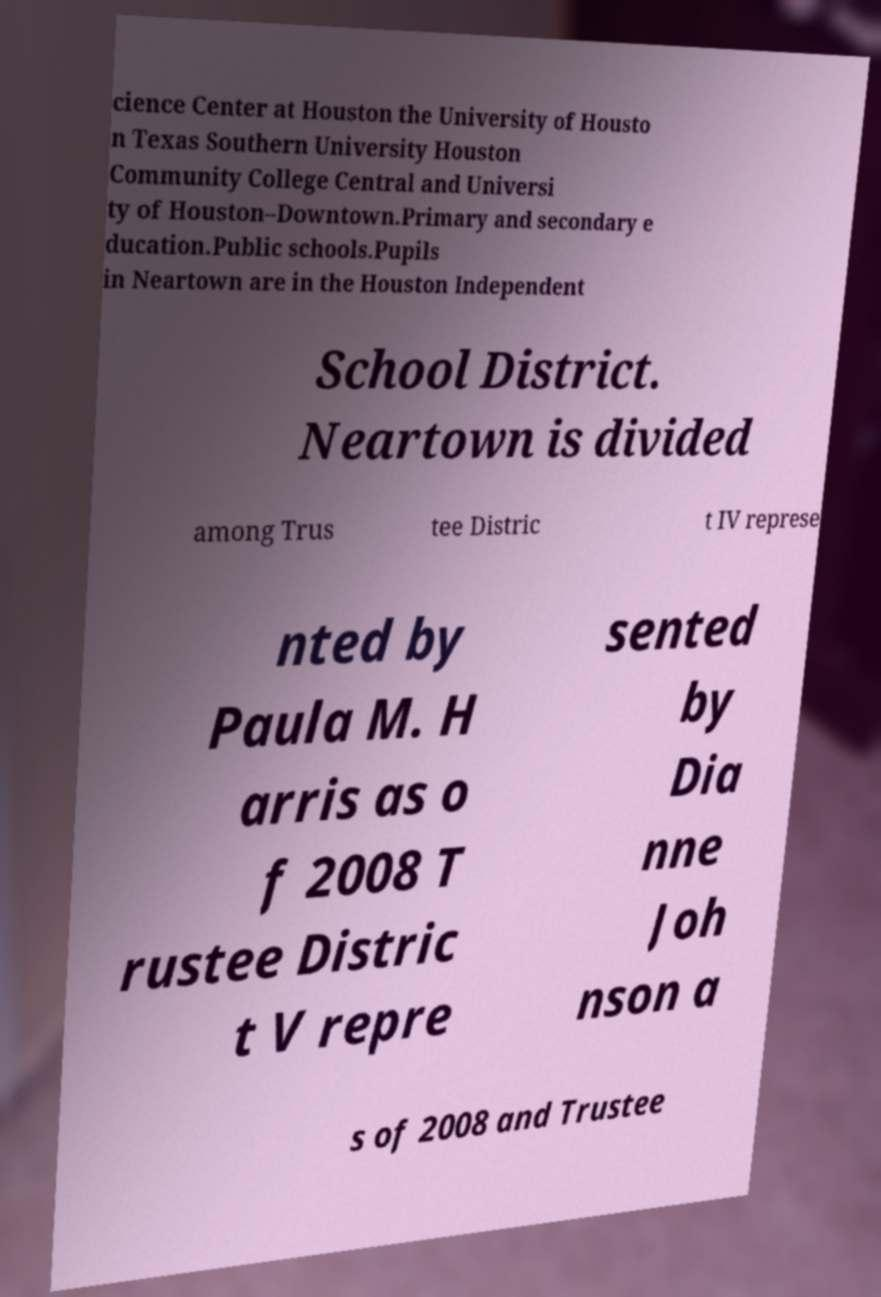Can you accurately transcribe the text from the provided image for me? cience Center at Houston the University of Housto n Texas Southern University Houston Community College Central and Universi ty of Houston–Downtown.Primary and secondary e ducation.Public schools.Pupils in Neartown are in the Houston Independent School District. Neartown is divided among Trus tee Distric t IV represe nted by Paula M. H arris as o f 2008 T rustee Distric t V repre sented by Dia nne Joh nson a s of 2008 and Trustee 